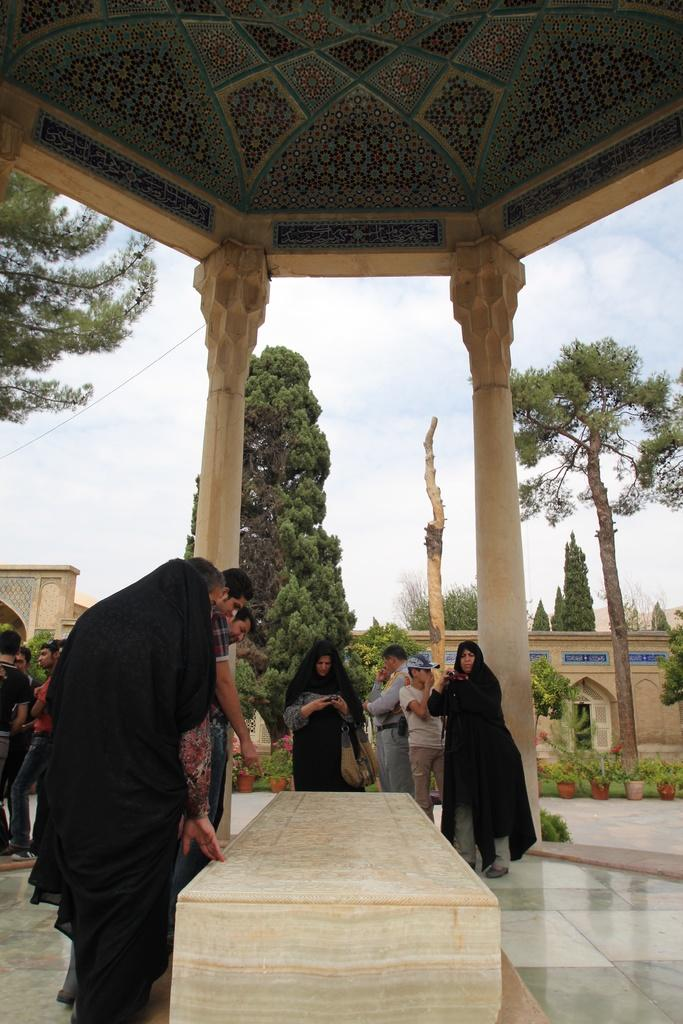What can be seen in the image besides the people? There is a historical construction, a tomb, trees, buildings, and the sky visible in the background of the image. What type of historical construction is near the people? The historical construction near the people is not specified in the facts, but it is mentioned that it is a historical construction. What is the natural setting visible in the image? The natural setting includes trees in the background. What can be seen in the sky in the image? The sky is visible in the background of the image, but no specific details about the sky are provided in the facts. What type of stocking is hanging from the historical construction in the image? There is no stocking hanging from the historical construction in the image. How many chickens are visible near the tomb in the image? There are no chickens visible near the tomb in the image. 